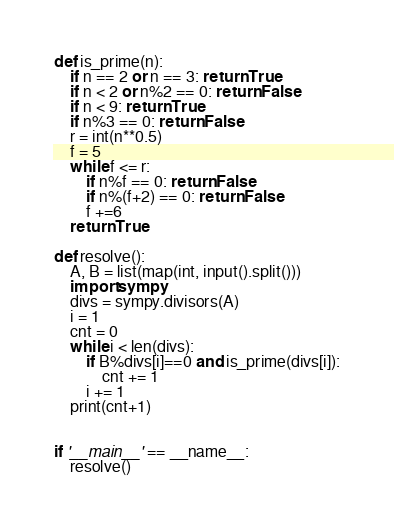<code> <loc_0><loc_0><loc_500><loc_500><_Python_>def is_prime(n):
    if n == 2 or n == 3: return True
    if n < 2 or n%2 == 0: return False
    if n < 9: return True
    if n%3 == 0: return False
    r = int(n**0.5)
    f = 5
    while f <= r:
        if n%f == 0: return False
        if n%(f+2) == 0: return False
        f +=6
    return True  

def resolve():
    A, B = list(map(int, input().split()))
    import sympy
    divs = sympy.divisors(A)
    i = 1
    cnt = 0
    while i < len(divs):
        if B%divs[i]==0 and is_prime(divs[i]):
            cnt += 1
        i += 1
    print(cnt+1)
    

if '__main__' == __name__:
    resolve()
</code> 